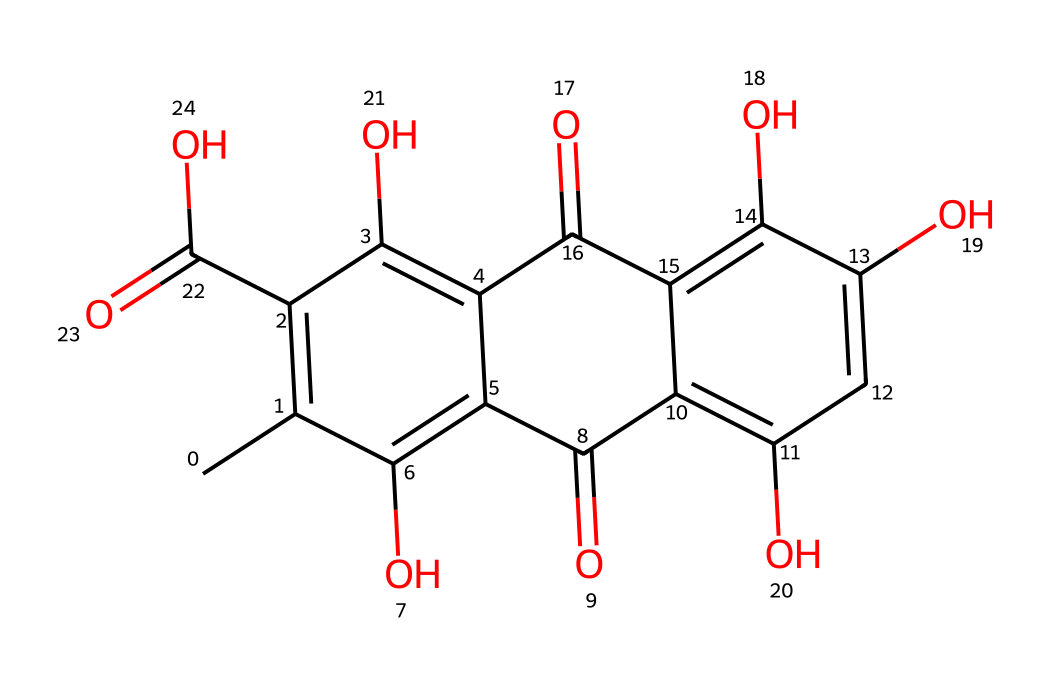What is the molecular formula of carmine? To determine the molecular formula, we need to count the atoms of each element present in the SMILES representation. By analyzing the structure, we find that there are 22 carbon atoms, 20 hydrogen atoms, 10 oxygen atoms, and no nitrogen or other atoms. Therefore, the molecular formula is C22H20O10.
Answer: C22H20O10 How many hydroxyl (-OH) groups are in the structure? By examining the chemical structure, we can observe the presence of hydroxyl groups. In this case, there are four hydroxyl (–OH) groups attached to the benzene ring, indicated by the 'O' atoms connected to 'H' groups.
Answer: 4 Which ring structure is present in carmine? A careful examination of the chemical structure reveals the presence of a fused ring system, consisting of both aromatic and non-aromatic components. Specifically, two fused aromatic rings can be identified.
Answer: fused aromatic rings What functional groups are present in carmine? By identifying various components of the structure, we can note multiple functional groups. In this case, the molecule contains hydroxyl (-OH), carbonyl (C=O), and carboxylic acid (-COOH) functional groups.
Answer: hydroxyl, carbonyl, carboxylic acid Is carmine soluble in water? Considering the presence of multiple hydroxyl and polar functional groups, we can conclude that the molecule exhibits hydrophilic properties, making it soluble in water.
Answer: soluble What color does carmine produce? The chemical structure of carmine suggests that it contains chromophore systems responsible for its deep red coloration. Therefore, the color produced by carmine is red.
Answer: red 